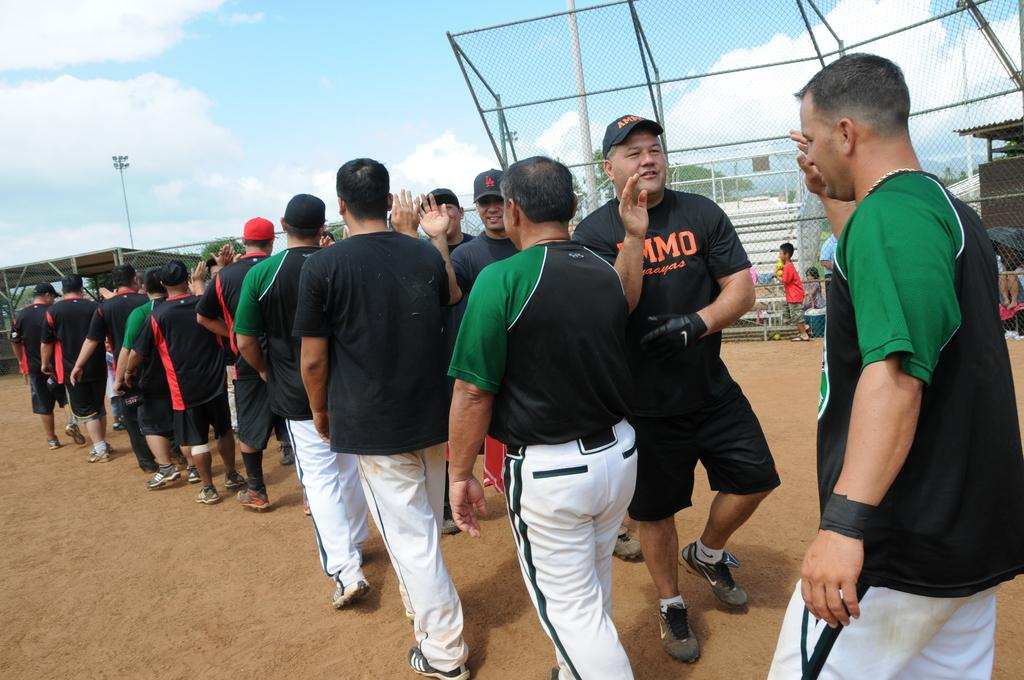<image>
Present a compact description of the photo's key features. A man is in a black shirt with the letters M and O visible. 